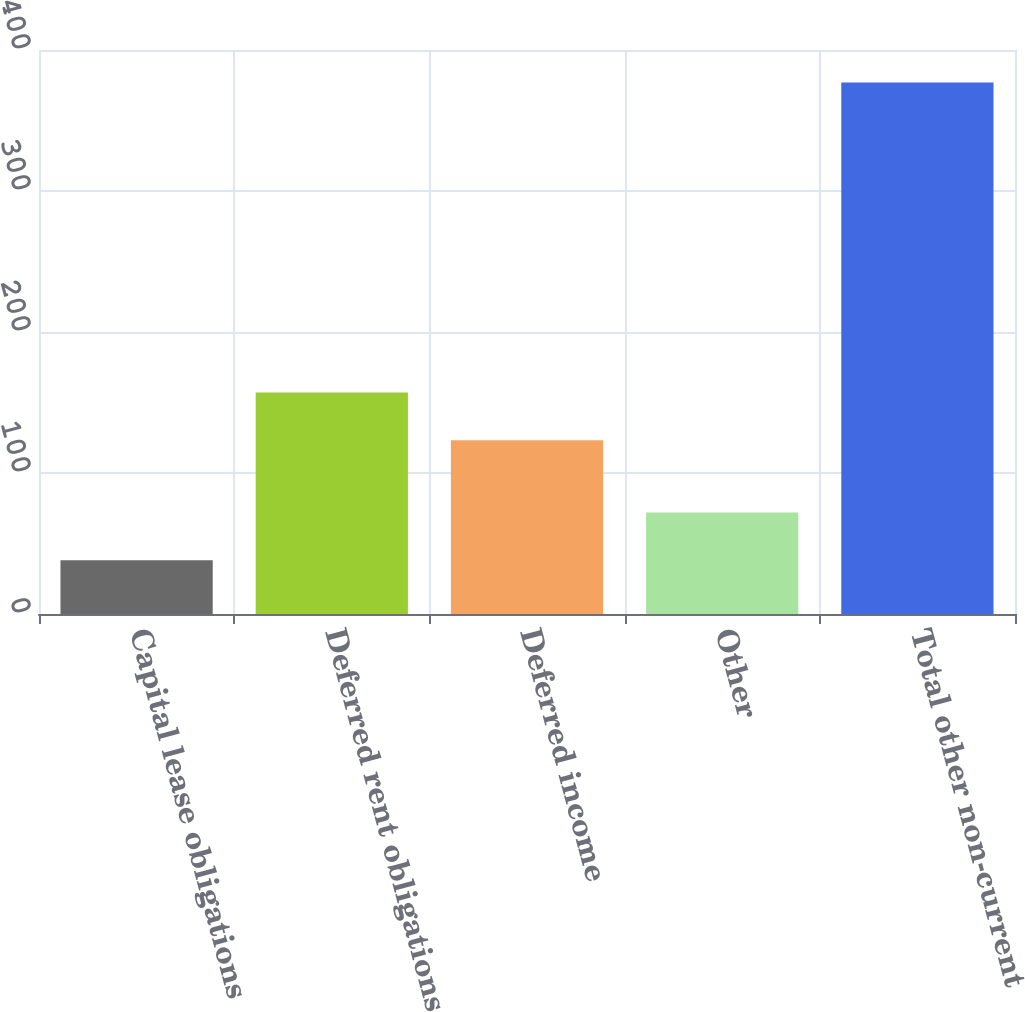Convert chart to OTSL. <chart><loc_0><loc_0><loc_500><loc_500><bar_chart><fcel>Capital lease obligations<fcel>Deferred rent obligations<fcel>Deferred income<fcel>Other<fcel>Total other non-current<nl><fcel>38.2<fcel>157.17<fcel>123.3<fcel>72.07<fcel>376.9<nl></chart> 